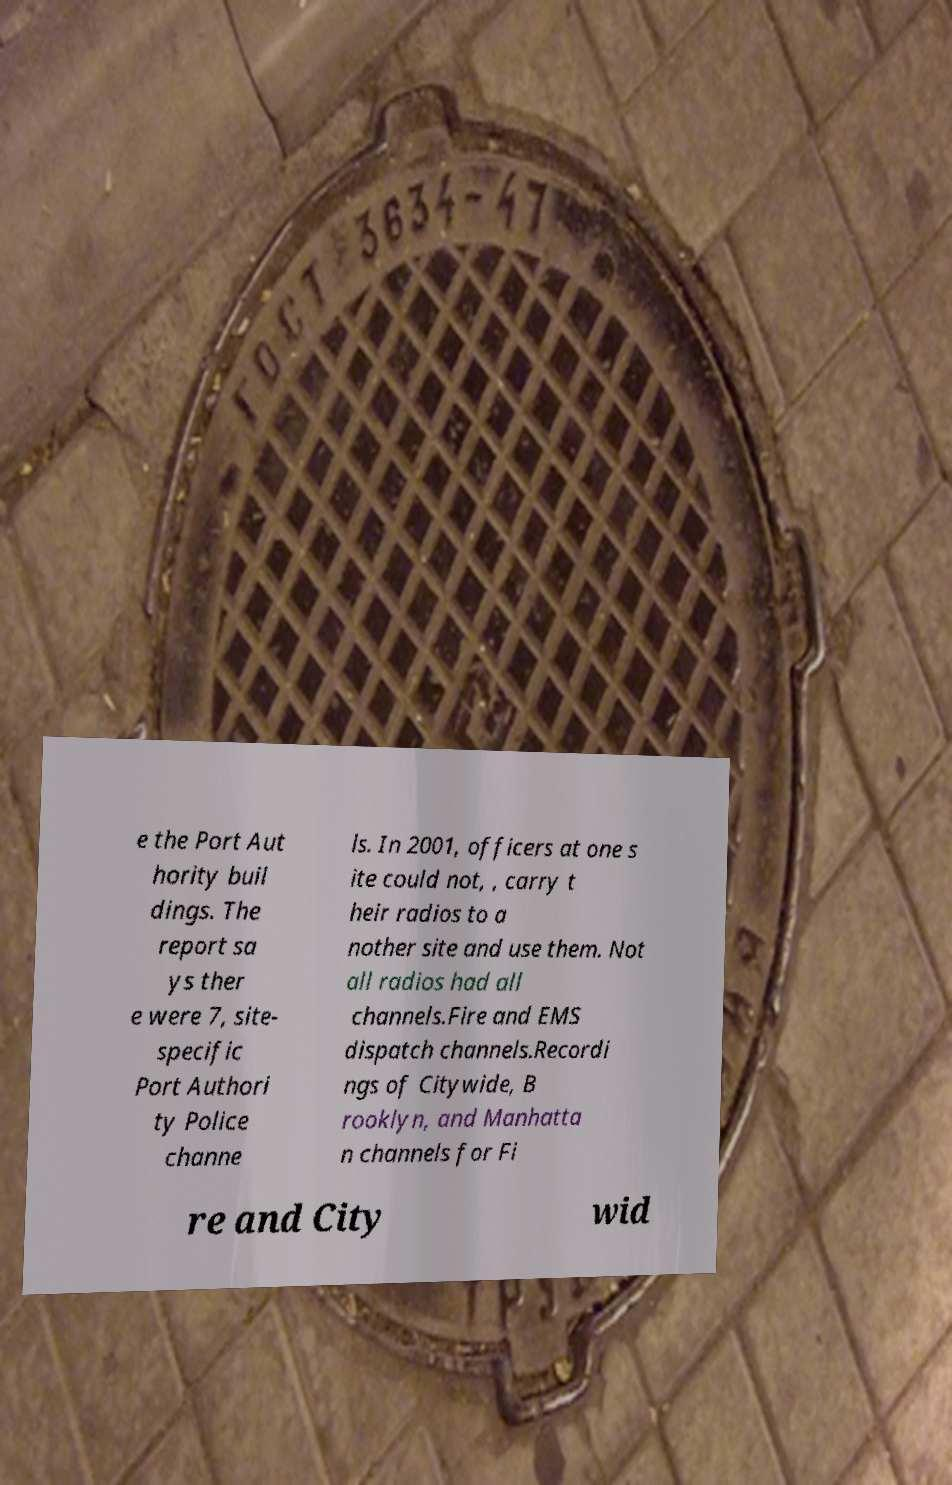Could you assist in decoding the text presented in this image and type it out clearly? e the Port Aut hority buil dings. The report sa ys ther e were 7, site- specific Port Authori ty Police channe ls. In 2001, officers at one s ite could not, , carry t heir radios to a nother site and use them. Not all radios had all channels.Fire and EMS dispatch channels.Recordi ngs of Citywide, B rooklyn, and Manhatta n channels for Fi re and City wid 